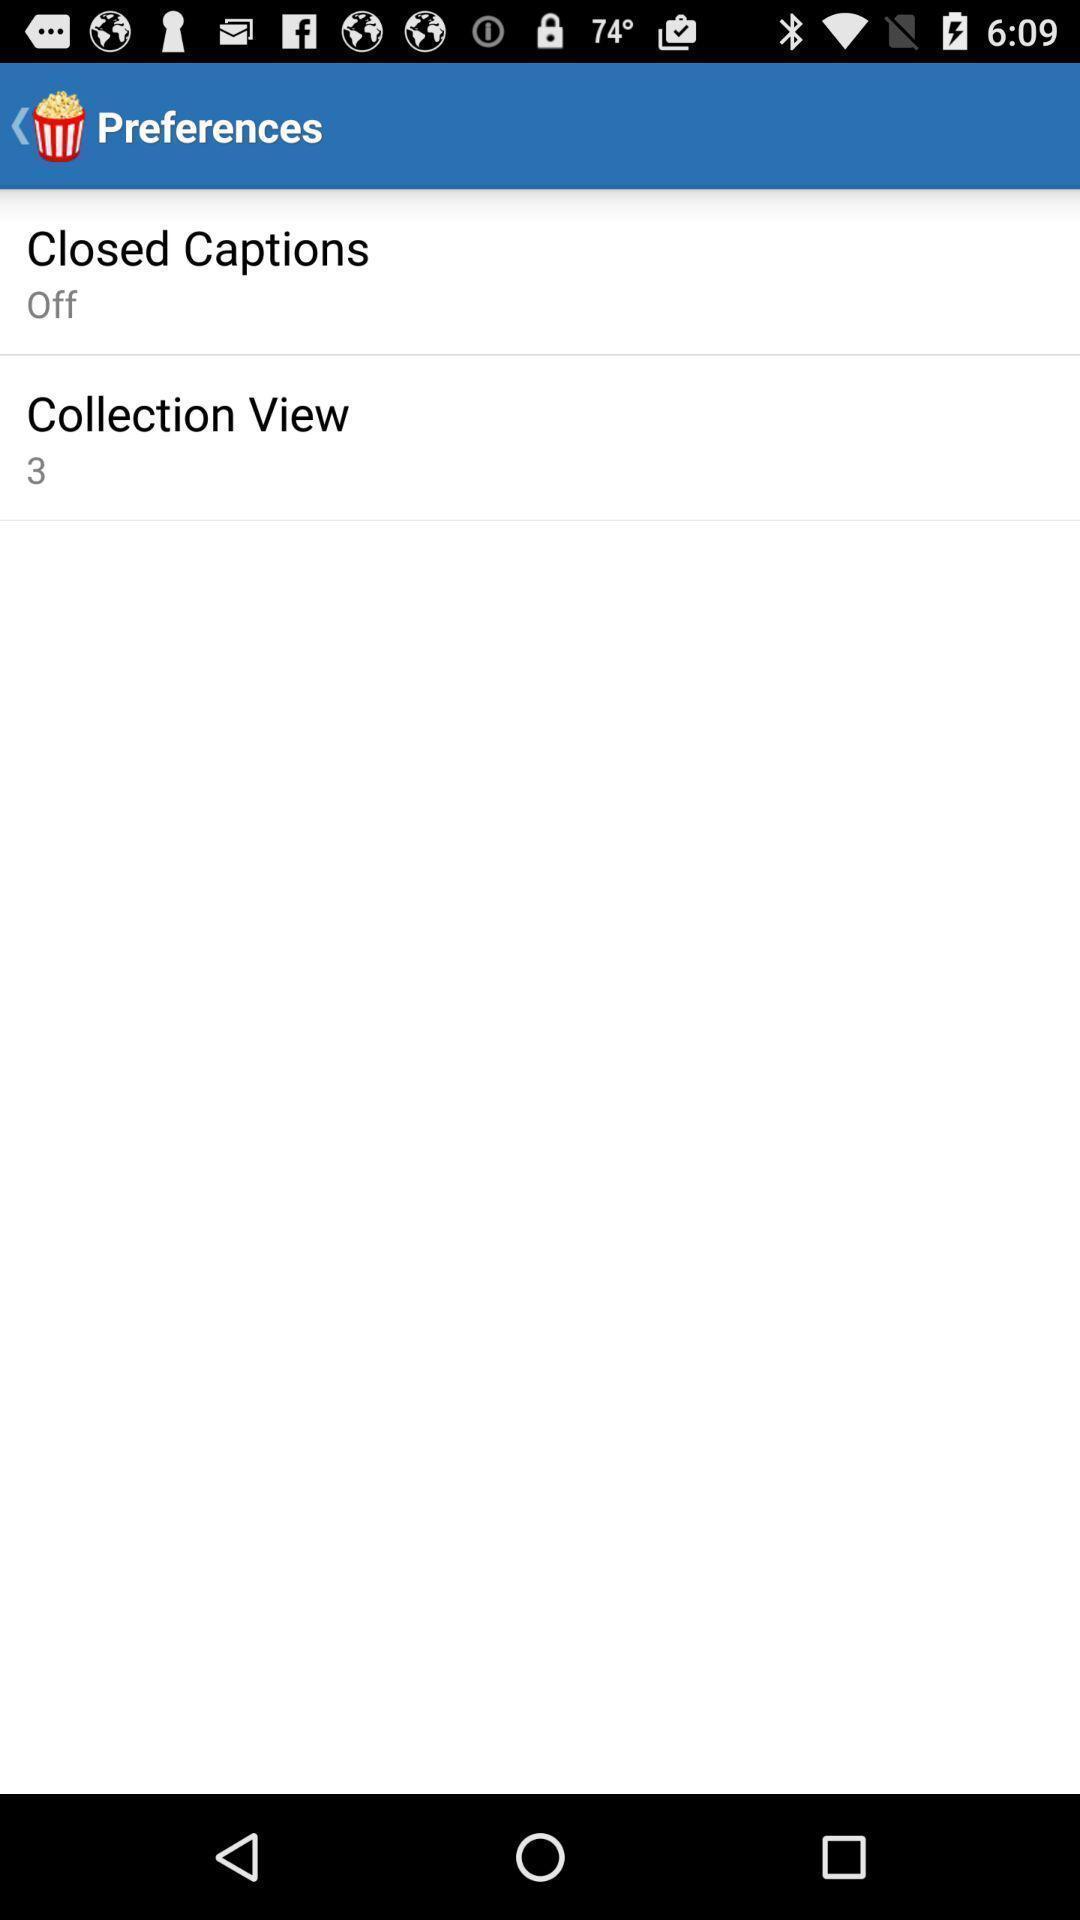Give me a narrative description of this picture. Screen shows multiple options. 